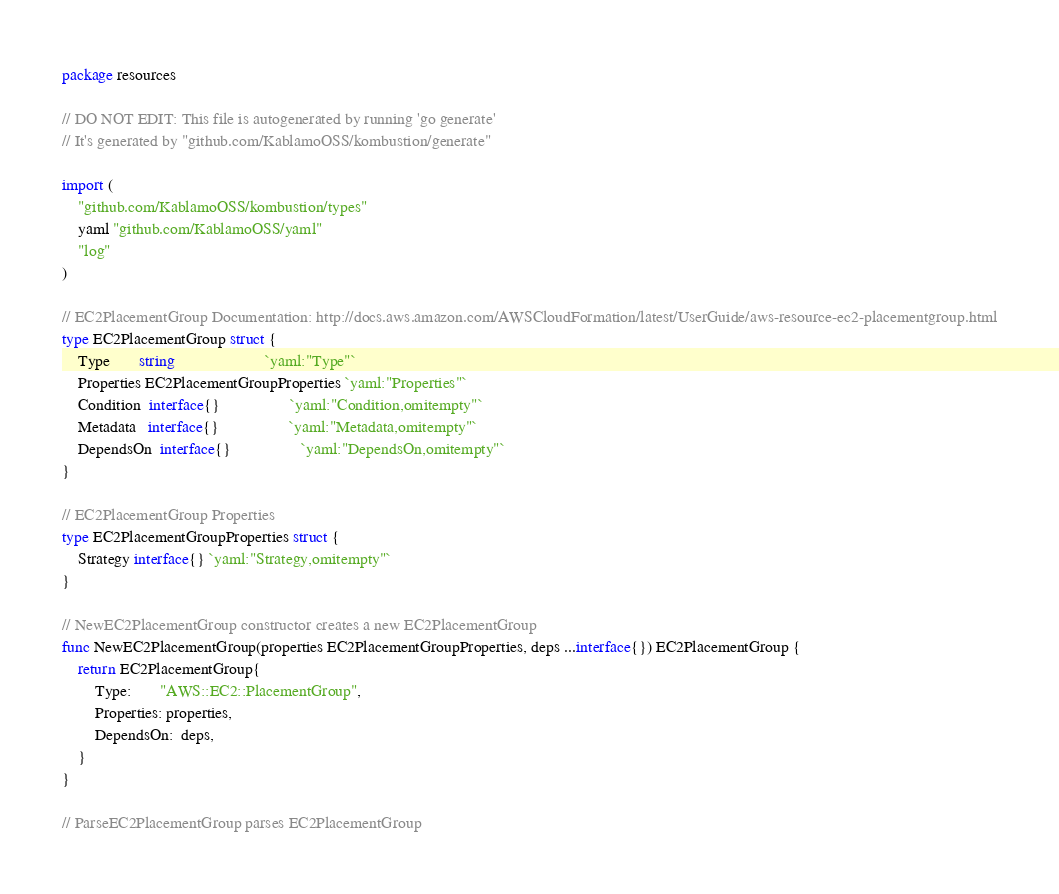<code> <loc_0><loc_0><loc_500><loc_500><_Go_>package resources

// DO NOT EDIT: This file is autogenerated by running 'go generate'
// It's generated by "github.com/KablamoOSS/kombustion/generate"

import (
	"github.com/KablamoOSS/kombustion/types"
	yaml "github.com/KablamoOSS/yaml"
	"log"
)

// EC2PlacementGroup Documentation: http://docs.aws.amazon.com/AWSCloudFormation/latest/UserGuide/aws-resource-ec2-placementgroup.html
type EC2PlacementGroup struct {
	Type       string                      `yaml:"Type"`
	Properties EC2PlacementGroupProperties `yaml:"Properties"`
	Condition  interface{}                 `yaml:"Condition,omitempty"`
	Metadata   interface{}                 `yaml:"Metadata,omitempty"`
	DependsOn  interface{}                 `yaml:"DependsOn,omitempty"`
}

// EC2PlacementGroup Properties
type EC2PlacementGroupProperties struct {
	Strategy interface{} `yaml:"Strategy,omitempty"`
}

// NewEC2PlacementGroup constructor creates a new EC2PlacementGroup
func NewEC2PlacementGroup(properties EC2PlacementGroupProperties, deps ...interface{}) EC2PlacementGroup {
	return EC2PlacementGroup{
		Type:       "AWS::EC2::PlacementGroup",
		Properties: properties,
		DependsOn:  deps,
	}
}

// ParseEC2PlacementGroup parses EC2PlacementGroup</code> 